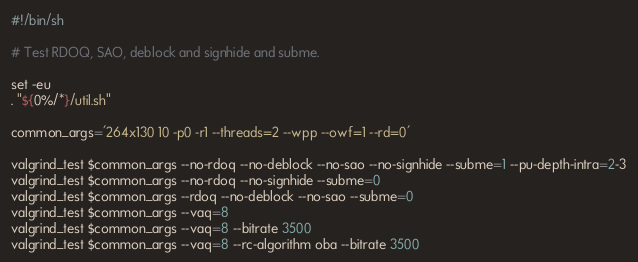Convert code to text. <code><loc_0><loc_0><loc_500><loc_500><_Bash_>#!/bin/sh

# Test RDOQ, SAO, deblock and signhide and subme.

set -eu
. "${0%/*}/util.sh"

common_args='264x130 10 -p0 -r1 --threads=2 --wpp --owf=1 --rd=0'

valgrind_test $common_args --no-rdoq --no-deblock --no-sao --no-signhide --subme=1 --pu-depth-intra=2-3
valgrind_test $common_args --no-rdoq --no-signhide --subme=0
valgrind_test $common_args --rdoq --no-deblock --no-sao --subme=0
valgrind_test $common_args --vaq=8
valgrind_test $common_args --vaq=8 --bitrate 3500
valgrind_test $common_args --vaq=8 --rc-algorithm oba --bitrate 3500
</code> 